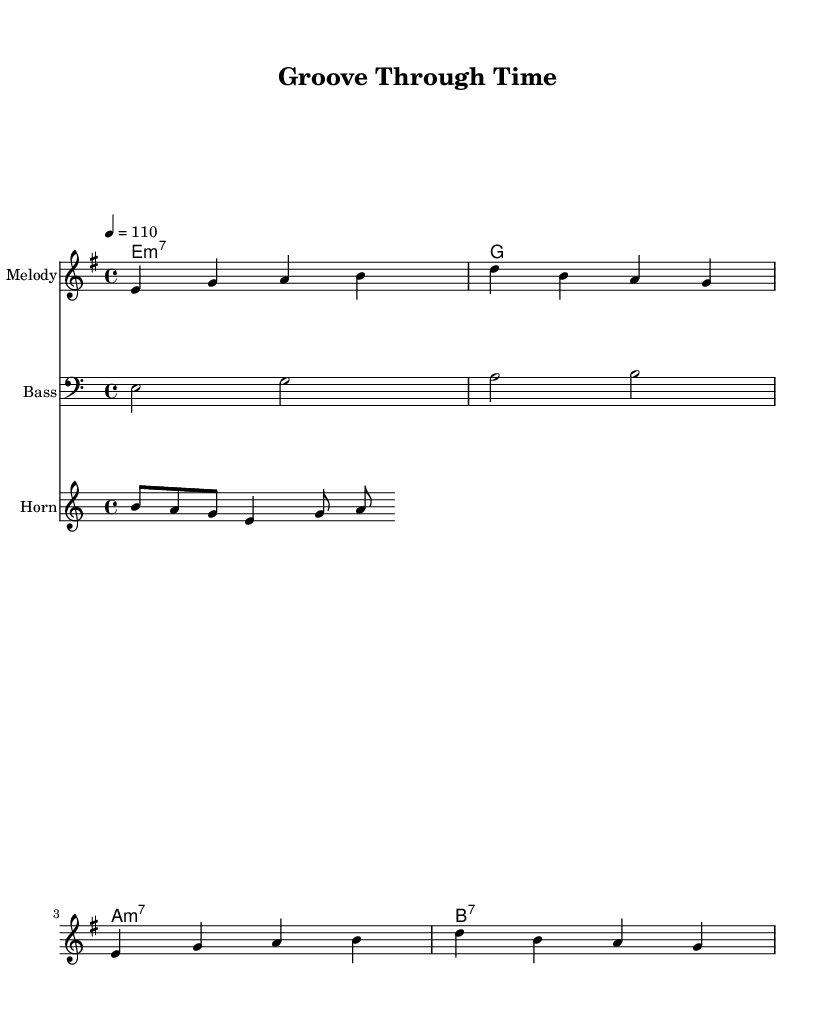What is the key signature of this music? The key signature is E minor, which is indicated by one sharp (F#) on the staff. In this case, it is represented by the minor chord at the start of the piece.
Answer: E minor What is the time signature of this music? The time signature is 4/4, which means there are four beats per measure, indicated at the beginning of the score.
Answer: 4/4 What is the tempo marking of this music? The tempo marking indicates a speed of 110 beats per minute, shown at the start of the music as "4 = 110."
Answer: 110 What is the first chord in the piece? The first chord listed in the chord names is E minor 7, as seen in the chord chart in the score.
Answer: E minor 7 How many measures are in the melody section? The melody section consists of four measures, which can be counted by the number of vertical bar lines separating the notes.
Answer: 4 Which instrument plays the horn melody? The instrument designated to play the horn melody is simply labeled as "Horn" in the score, indicating that it features horn instrumentation.
Answer: Horn What style does this music represent? The music represents the Funk style, characterized by its rhythm and groove, making it clear from the chord selections and overall upbeat tempo designed to celebrate resilience.
Answer: Funk 